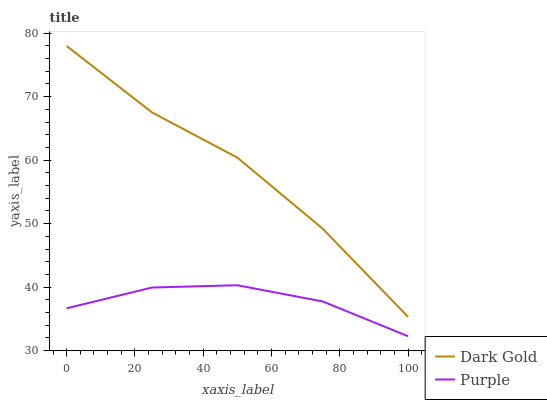Does Purple have the minimum area under the curve?
Answer yes or no. Yes. Does Dark Gold have the maximum area under the curve?
Answer yes or no. Yes. Does Dark Gold have the minimum area under the curve?
Answer yes or no. No. Is Purple the smoothest?
Answer yes or no. Yes. Is Dark Gold the roughest?
Answer yes or no. Yes. Is Dark Gold the smoothest?
Answer yes or no. No. Does Purple have the lowest value?
Answer yes or no. Yes. Does Dark Gold have the lowest value?
Answer yes or no. No. Does Dark Gold have the highest value?
Answer yes or no. Yes. Is Purple less than Dark Gold?
Answer yes or no. Yes. Is Dark Gold greater than Purple?
Answer yes or no. Yes. Does Purple intersect Dark Gold?
Answer yes or no. No. 